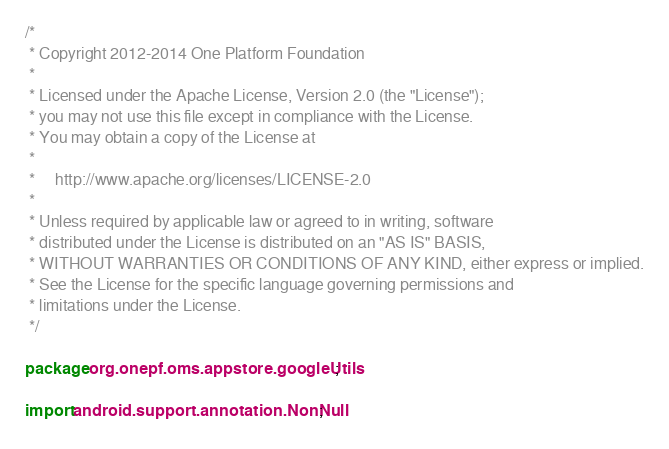Convert code to text. <code><loc_0><loc_0><loc_500><loc_500><_Java_>/*
 * Copyright 2012-2014 One Platform Foundation
 *
 * Licensed under the Apache License, Version 2.0 (the "License");
 * you may not use this file except in compliance with the License.
 * You may obtain a copy of the License at
 *
 *     http://www.apache.org/licenses/LICENSE-2.0
 *
 * Unless required by applicable law or agreed to in writing, software
 * distributed under the License is distributed on an "AS IS" BASIS,
 * WITHOUT WARRANTIES OR CONDITIONS OF ANY KIND, either express or implied.
 * See the License for the specific language governing permissions and
 * limitations under the License.
 */

package org.onepf.oms.appstore.googleUtils;

import android.support.annotation.NonNull;</code> 